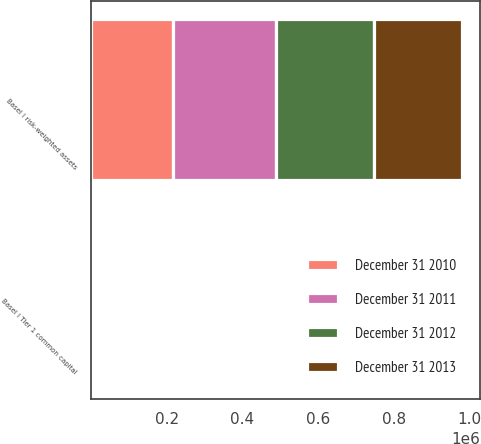Convert chart. <chart><loc_0><loc_0><loc_500><loc_500><stacked_bar_chart><ecel><fcel>Basel I Tier 1 common capital<fcel>Basel I risk-weighted assets<nl><fcel>December 31 2011<fcel>10.5<fcel>272169<nl><fcel>December 31 2012<fcel>9.6<fcel>260847<nl><fcel>December 31 2013<fcel>10.3<fcel>230705<nl><fcel>December 31 2010<fcel>9.8<fcel>216283<nl></chart> 